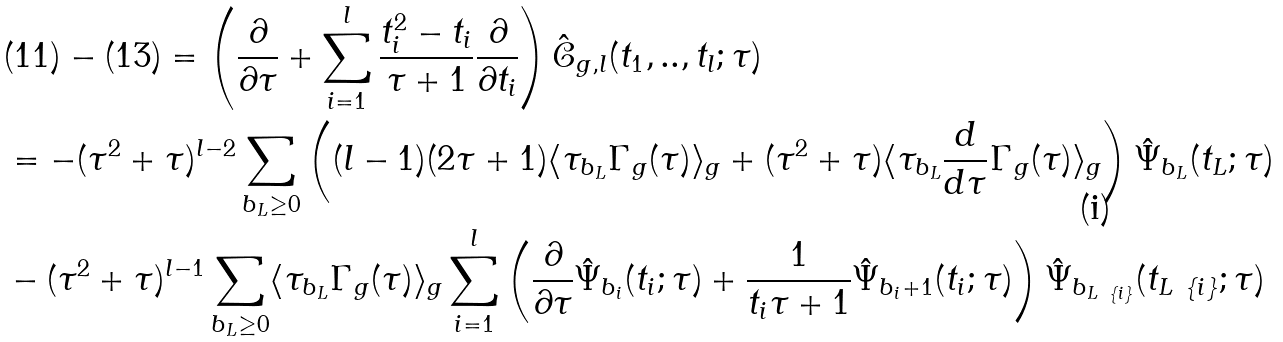<formula> <loc_0><loc_0><loc_500><loc_500>& ( 1 1 ) - ( 1 3 ) = \left ( \frac { \partial } { \partial \tau } + \sum _ { i = 1 } ^ { l } \frac { t _ { i } ^ { 2 } - t _ { i } } { \tau + 1 } \frac { \partial } { \partial t _ { i } } \right ) \hat { \mathcal { C } } _ { g , l } ( t _ { 1 } , . . , t _ { l } ; \tau ) \\ & = - ( \tau ^ { 2 } + \tau ) ^ { l - 2 } \sum _ { b _ { L } \geq 0 } \left ( ( l - 1 ) ( 2 \tau + 1 ) \langle \tau _ { b _ { L } } \Gamma _ { g } ( \tau ) \rangle _ { g } + ( \tau ^ { 2 } + \tau ) \langle \tau _ { b _ { L } } \frac { d } { d \tau } \Gamma _ { g } ( \tau ) \rangle _ { g } \right ) \hat { \Psi } _ { b _ { L } } ( t _ { L } ; \tau ) \\ & - ( \tau ^ { 2 } + \tau ) ^ { l - 1 } \sum _ { b _ { L } \geq 0 } \langle \tau _ { b _ { L } } \Gamma _ { g } ( \tau ) \rangle _ { g } \sum _ { i = 1 } ^ { l } \left ( \frac { \partial } { \partial \tau } \hat { \Psi } _ { b _ { i } } ( t _ { i } ; \tau ) + \frac { 1 } { t _ { i } \tau + 1 } \hat { \Psi } _ { b _ { i } + 1 } ( t _ { i } ; \tau ) \right ) \hat { \Psi } _ { b _ { L \ \{ i \} } } ( t _ { L \ \{ i \} } ; \tau )</formula> 